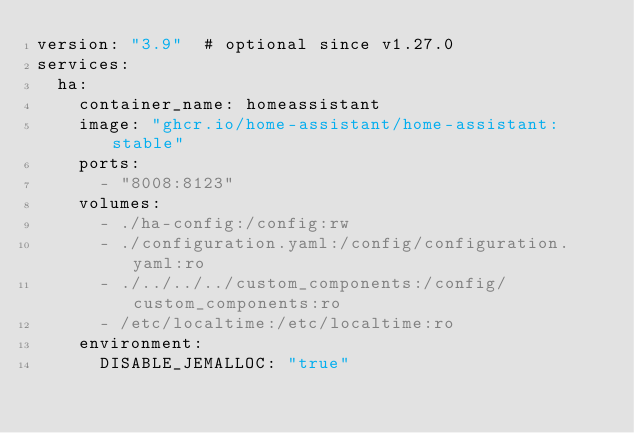Convert code to text. <code><loc_0><loc_0><loc_500><loc_500><_YAML_>version: "3.9"  # optional since v1.27.0
services:
  ha:
    container_name: homeassistant
    image: "ghcr.io/home-assistant/home-assistant:stable"
    ports:
      - "8008:8123"
    volumes:
      - ./ha-config:/config:rw
      - ./configuration.yaml:/config/configuration.yaml:ro
      - ./../../../custom_components:/config/custom_components:ro
      - /etc/localtime:/etc/localtime:ro
    environment:
      DISABLE_JEMALLOC: "true"
</code> 